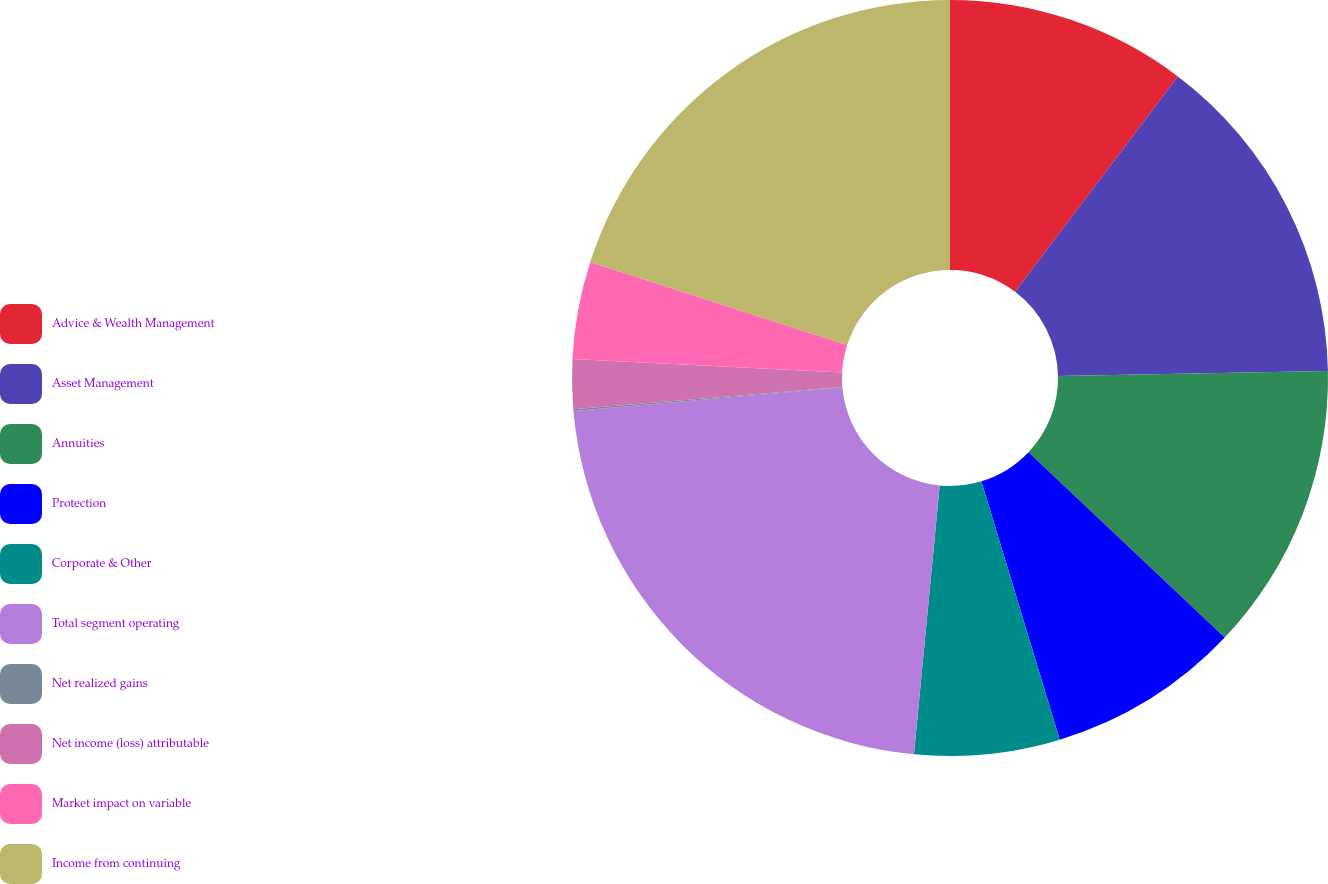Convert chart. <chart><loc_0><loc_0><loc_500><loc_500><pie_chart><fcel>Advice & Wealth Management<fcel>Asset Management<fcel>Annuities<fcel>Protection<fcel>Corporate & Other<fcel>Total segment operating<fcel>Net realized gains<fcel>Net income (loss) attributable<fcel>Market impact on variable<fcel>Income from continuing<nl><fcel>10.3%<fcel>14.4%<fcel>12.35%<fcel>8.26%<fcel>6.21%<fcel>22.09%<fcel>0.07%<fcel>2.12%<fcel>4.16%<fcel>20.04%<nl></chart> 